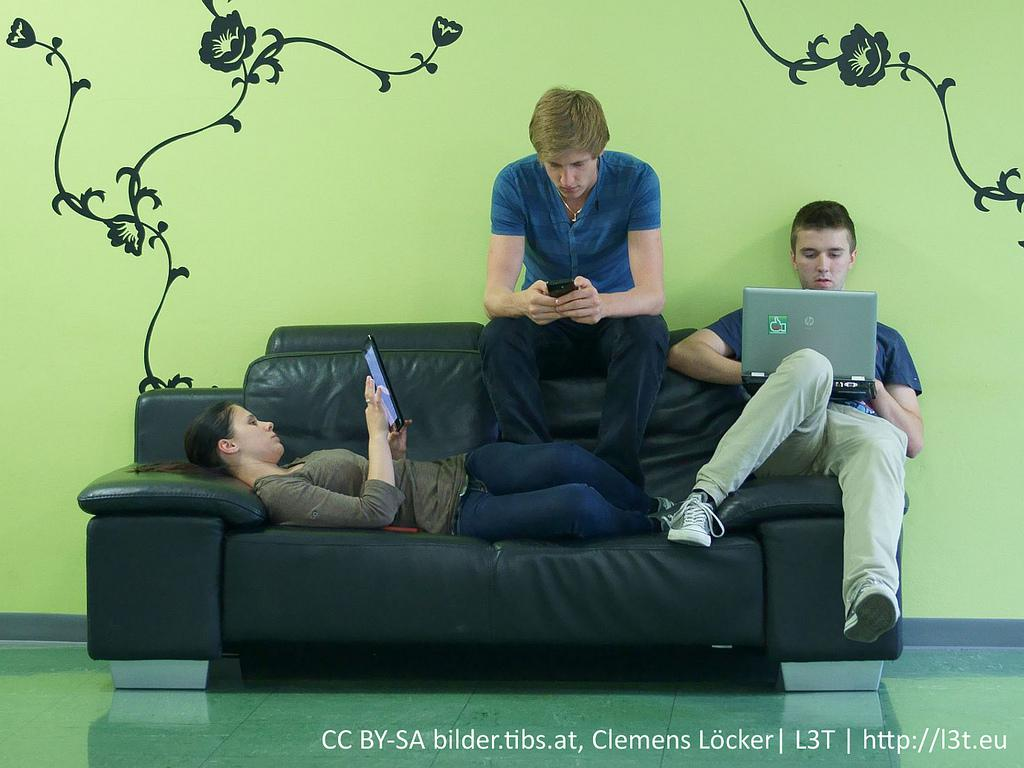Question: when will the couch be full?
Choices:
A. It will be full when two more people sit on it.
B. It will be full when three more people sit on it.
C. Now, it already is.
D. It will be full when I put another basket of laundry on it.
Answer with the letter. Answer: C Question: how many people are there?
Choices:
A. One.
B. Two.
C. Three.
D. Five.
Answer with the letter. Answer: C Question: what sort of pattern is on the wall?
Choices:
A. Paisley.
B. Plants.
C. A floral pattern.
D. Roses.
Answer with the letter. Answer: C Question: who is holding a laptop?
Choices:
A. A young man sitting.
B. A boy that is sitting on the right end of the couch.
C. A kid.
D. A youth.
Answer with the letter. Answer: B Question: what is the person sitting on top of the couch holding?
Choices:
A. A remote.
B. A mobile phone.
C. A telephone.
D. A video game remote.
Answer with the letter. Answer: B Question: how many boys wearing tennis shoes?
Choices:
A. One boy wearing tennis shoes.
B. Twotwo.
C. Four.
D. Five.
Answer with the letter. Answer: A Question: where is the blonde person?
Choices:
A. On top of the couch, in the middle of the other two people.
B. In the back.
C. Standing between two people.
D. Sitting.
Answer with the letter. Answer: A Question: what color is the hair of the man in the middle?
Choices:
A. Grey.
B. Dark blonde.
C. Light brown.
D. Dark green.
Answer with the letter. Answer: B Question: what is the man in the middle sitting on?
Choices:
A. Couch cushion.
B. Stool.
C. Back of the couch.
D. Recliner.
Answer with the letter. Answer: C Question: what are the people doing?
Choices:
A. Reading books.
B. Using technology.
C. Walking.
D. Playing in the park.
Answer with the letter. Answer: B Question: what is on the wall?
Choices:
A. Lavender paint.
B. Flower decal.
C. Photographs.
D. Wallpaper.
Answer with the letter. Answer: B Question: what color is the couch?
Choices:
A. Red.
B. Brown.
C. Black.
D. Tan.
Answer with the letter. Answer: C Question: what color is the woman's hair?
Choices:
A. Blonde.
B. Black.
C. Grey.
D. Dark brown.
Answer with the letter. Answer: D Question: what color are the walls?
Choices:
A. Grey.
B. Black.
C. Green.
D. Blue.
Answer with the letter. Answer: C Question: what is green and shiny?
Choices:
A. An emerald.
B. A traffic light.
C. A saint patricks day top hat.
D. Floor tiles.
Answer with the letter. Answer: D Question: who has short hair?
Choices:
A. That woman.
B. One lad.
C. The terrier.
D. The whole crowd.
Answer with the letter. Answer: B Question: how many necklaces the light haired boys wearing?
Choices:
A. Two.
B. None.
C. Four.
D. One necklace.
Answer with the letter. Answer: D Question: who is using the tablet?
Choices:
A. The boy standing up.
B. The girl sitting.
C. The man kneeling.
D. The woman laying down.
Answer with the letter. Answer: D Question: where is the man who is texting?
Choices:
A. The man is on the right.
B. The man is on the left.
C. The man is in the back.
D. The man is in the middle.
Answer with the letter. Answer: D Question: where is the light color on the couch?
Choices:
A. The light color is in the legs of the couch.
B. The light color is in the arms of the couch.
C. The light color is in the cushions.
D. The light color is in the pillows.
Answer with the letter. Answer: A Question: how many blue t-shirts are in the picture?
Choices:
A. One.
B. None.
C. Three.
D. Two mens wearing blue t-shirt.
Answer with the letter. Answer: D 